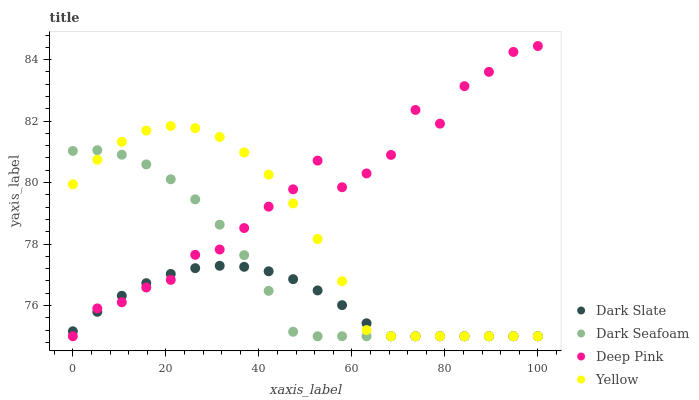Does Dark Slate have the minimum area under the curve?
Answer yes or no. Yes. Does Deep Pink have the maximum area under the curve?
Answer yes or no. Yes. Does Dark Seafoam have the minimum area under the curve?
Answer yes or no. No. Does Dark Seafoam have the maximum area under the curve?
Answer yes or no. No. Is Dark Slate the smoothest?
Answer yes or no. Yes. Is Deep Pink the roughest?
Answer yes or no. Yes. Is Dark Seafoam the smoothest?
Answer yes or no. No. Is Dark Seafoam the roughest?
Answer yes or no. No. Does Dark Slate have the lowest value?
Answer yes or no. Yes. Does Deep Pink have the highest value?
Answer yes or no. Yes. Does Dark Seafoam have the highest value?
Answer yes or no. No. Does Dark Slate intersect Dark Seafoam?
Answer yes or no. Yes. Is Dark Slate less than Dark Seafoam?
Answer yes or no. No. Is Dark Slate greater than Dark Seafoam?
Answer yes or no. No. 